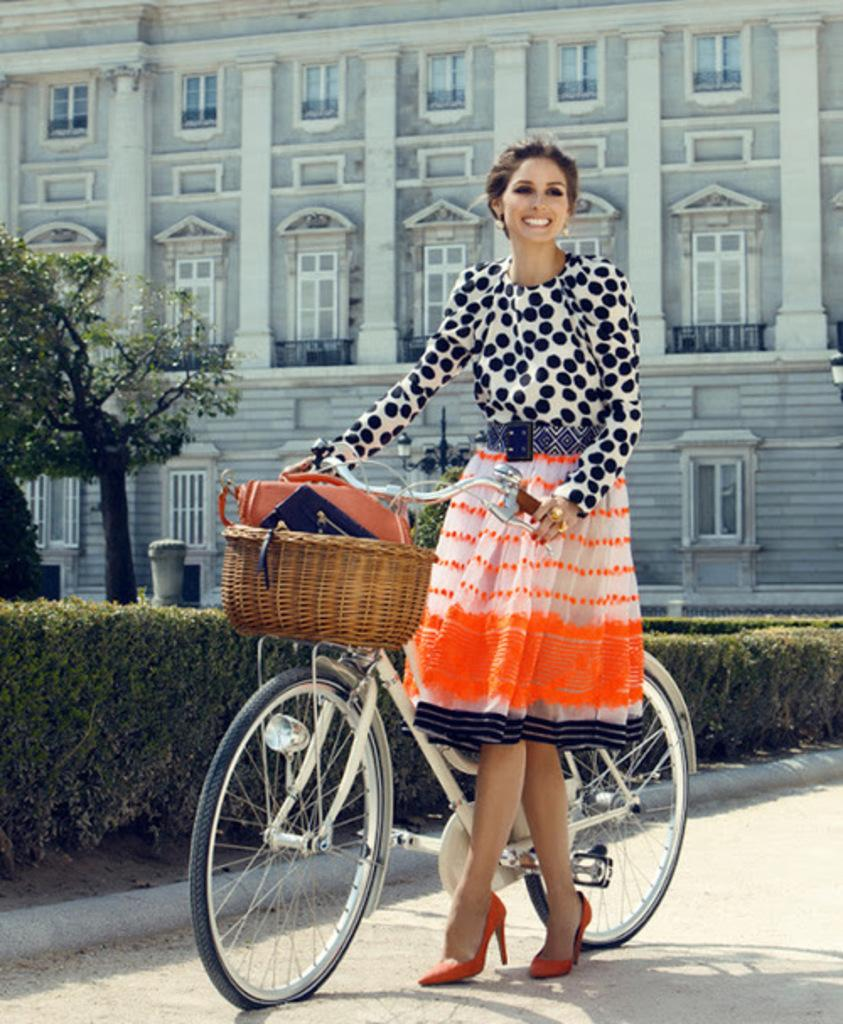Who is present in the image? There is a woman in the image. What is the woman doing in the image? The woman is standing on the ground and holding a bicycle. What type of vegetation can be seen in the image? There are plants and trees in the image. What type of structure is visible in the image? There is a building with windows in the image, and it has pillars. What type of comb can be seen in the woman's hair in the image? There is no comb visible in the woman's hair in the image. What type of thunder can be heard in the background of the image? There is no thunder present in the image, as it is a still photograph. 